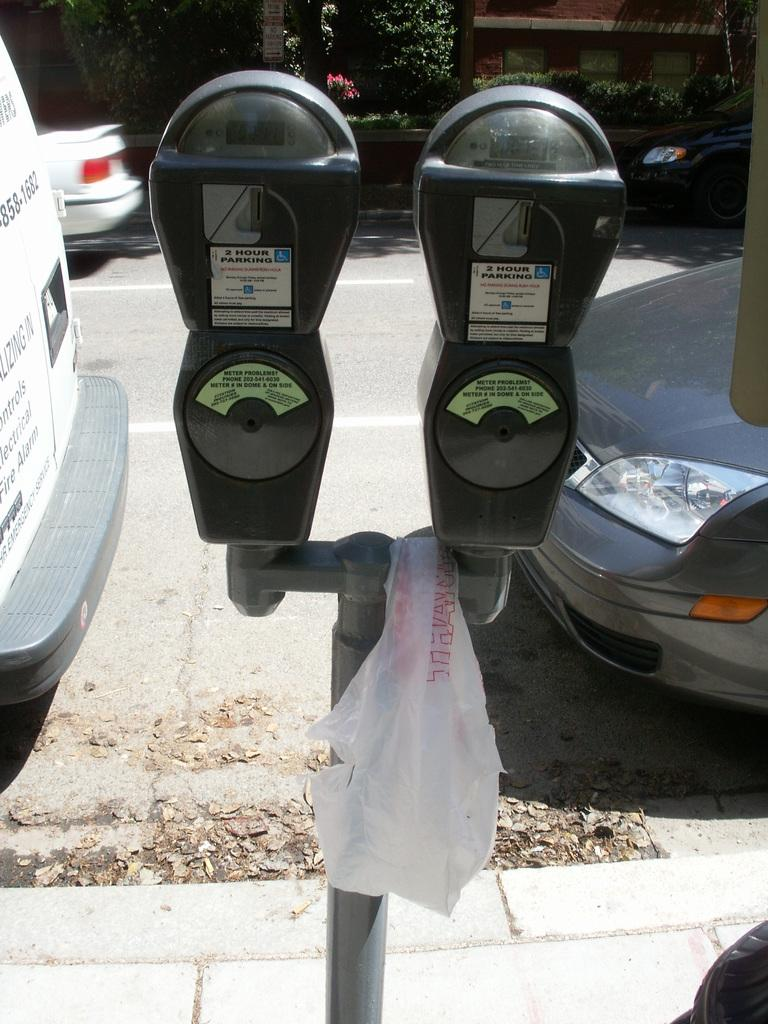<image>
Present a compact description of the photo's key features. Two parking meters that say 2 Hour Parking. 